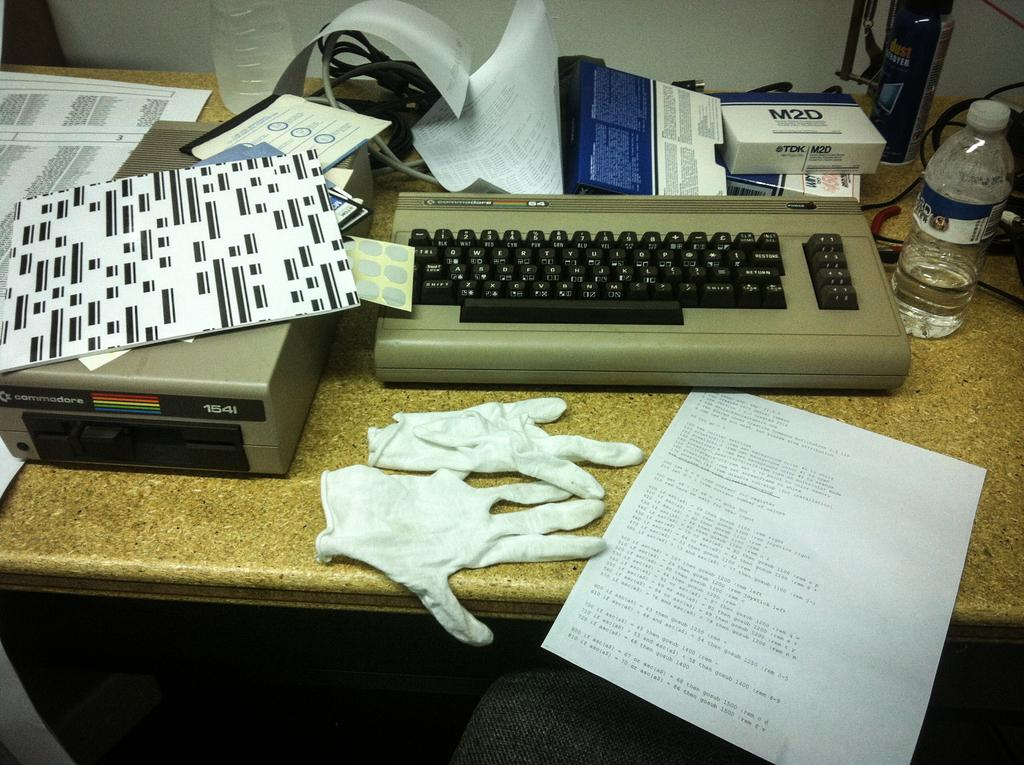<image>
Relay a brief, clear account of the picture shown. A box with the brand name M2D on it is on top of a typewriter. 